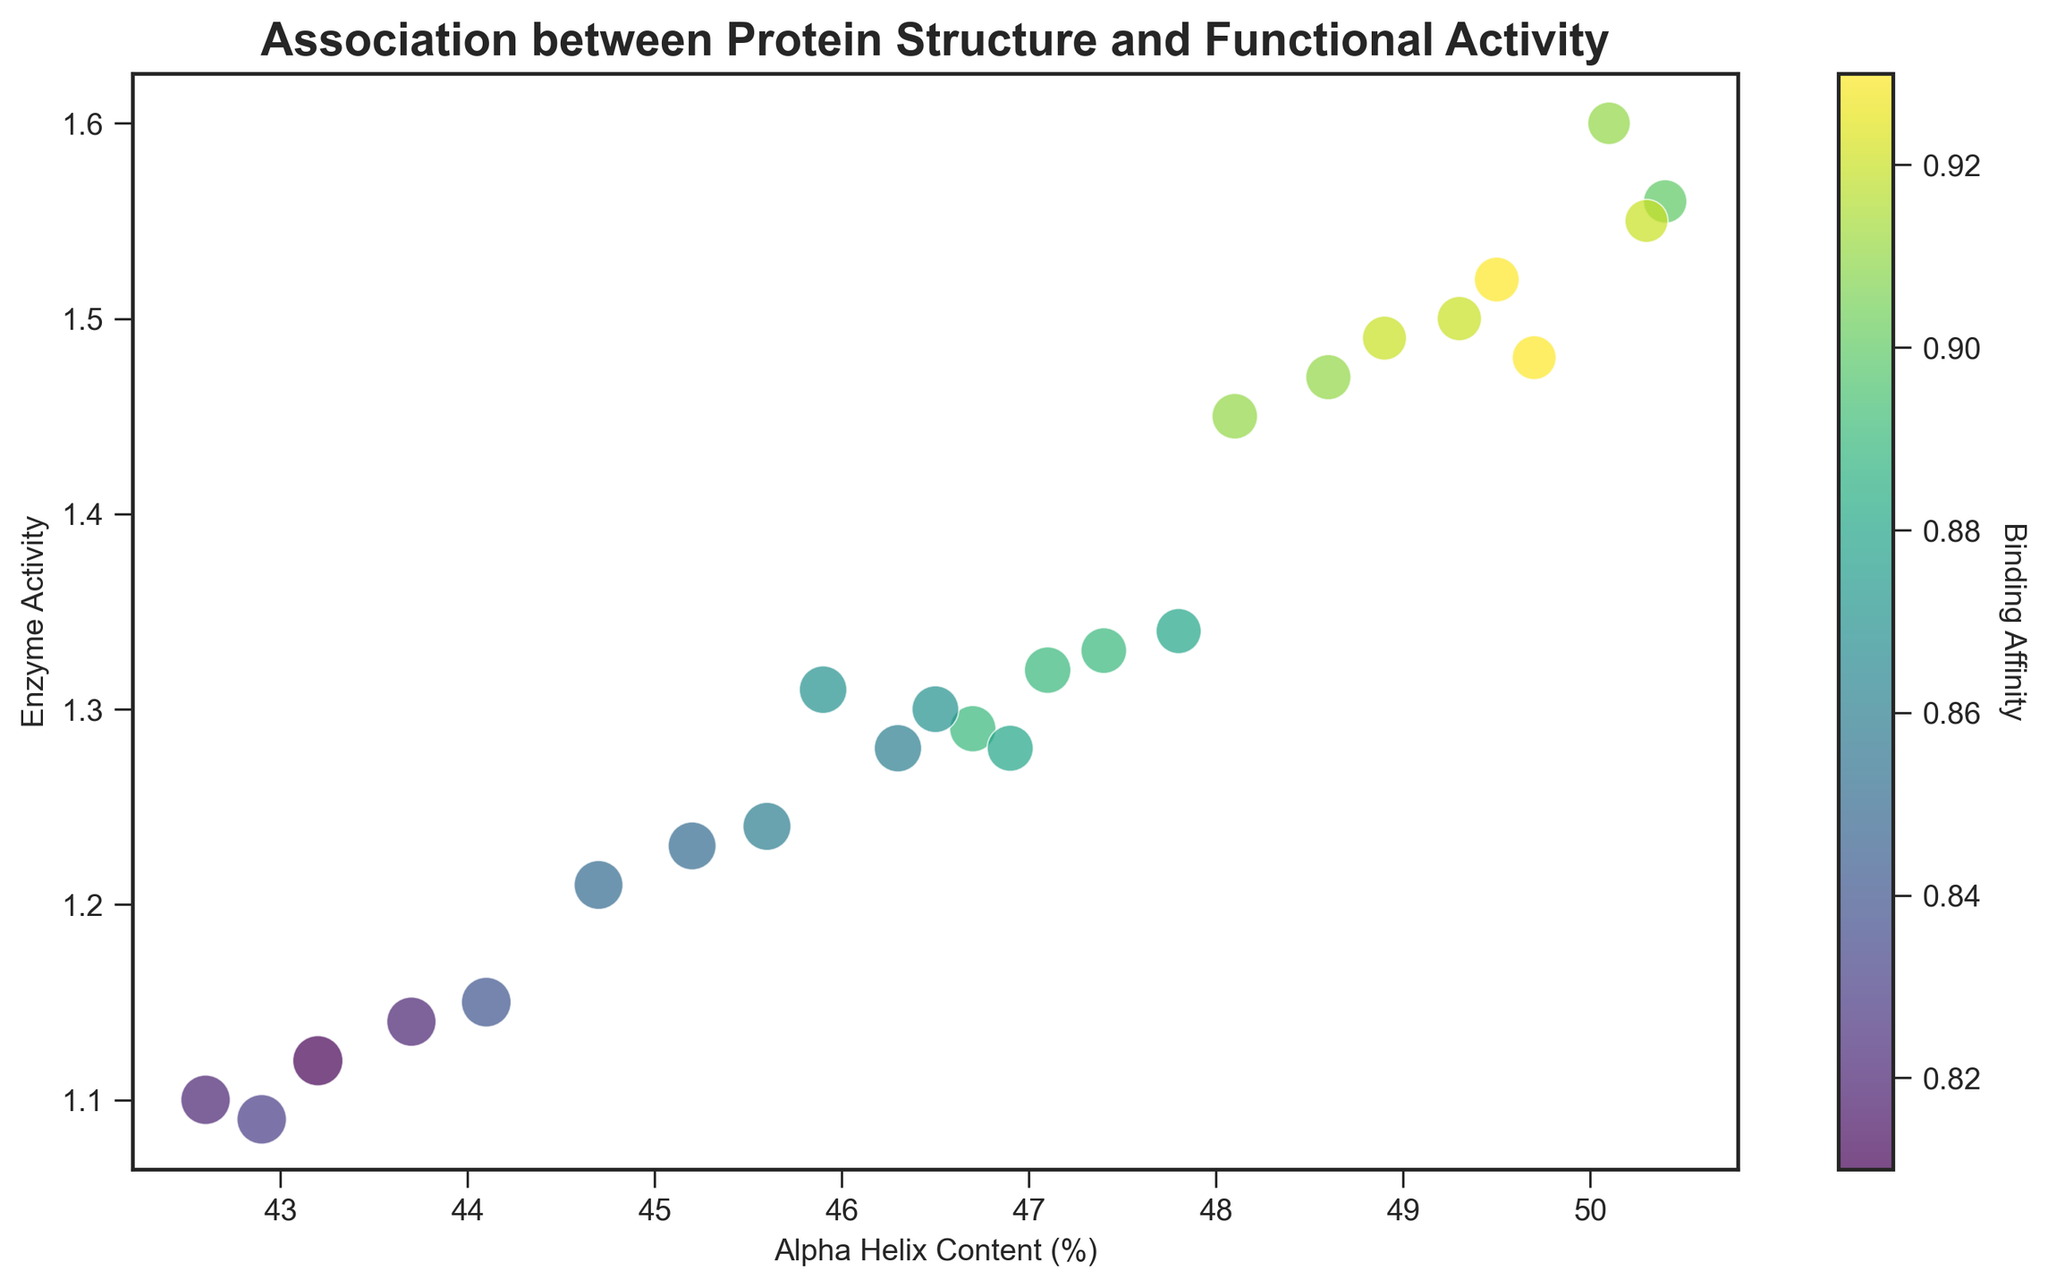What does the size of each point represent in the scatter plot? The size of each point in the scatter plot represents the Beta Sheet Content of the protein, with larger points indicating higher Beta Sheet Content.
Answer: Beta Sheet Content Which protein shows the highest enzyme activity, and what is its alpha helix content? By looking at the scatter plot, the highest enzyme activity is represented by the highest positioned point on the y-axis. The protein with the highest enzyme activity has an activity of 1.60 and an alpha helix content of 50.1%.
Answer: P9, 50.1% How is the Binding Affinity visually represented in the scatter plot? The Binding Affinity is represented by the color intensity of each point. Points with higher Binding Affinities are colored in a more intense color on the viridis scale, which varies from blue to yellow.
Answer: Color intensity What relationship can be observed between Alpha Helix Content and Enzyme Activity for the proteins with the highest Binding Affinity? By observing the points with the highest color intensity (yellow), we can see they generally have high alpha helix content and high enzyme activity, suggesting a positive relationship between these attributes for high Binding Affinity proteins.
Answer: Positive relationship Which protein has the smallest Beta Sheet Content and what is its Binding Affinity? Look for the smallest points in the scatter plot to find the protein with the smallest Beta Sheet Content. The smallest point corresponds to a Beta Sheet Content of 19.8, with a Binding Affinity of 0.91.
Answer: P9, 0.91 Is there any protein with a high Alpha Helix Content but relatively low Enzyme Activity? Identify points on the far right of the x-axis (high alpha helix content) but low on the y-axis (low enzyme activity). Protein P19 has 50.3% alpha helix content but only 1.55 enzyme activity, which is relatively lower compared to other high alpha helix content proteins.
Answer: Yes, P19 Considering the Binding Affinity, which region of the scatter plot tends to have lower values and how is this indicated? Lower Binding Affinity values are indicated by darker blue colors in the scatter plot and are generally found in the lower left region, corresponding to lower alpha helix content and lower enzyme activity.
Answer: Lower left region Comparing P8 and P14, which one has a higher Beta Sheet Content and which has a higher Enzyme Activity? Compare the size and position of the points representing P8 and P14. P8's point is larger (indicating higher Beta Sheet Content of 22.0) and positioned higher on the y-axis (indicating higher Enzyme Activity of 1.52) than P14, which has a Beta Sheet Content of 21.1 and Enzyme Activity of 1.48.
Answer: P8 for both What trend can be observed between the Alpha Helix Content and Binding Affinity? Observe the scatter plot for patterns in color along the x-axis. Generally, as the Alpha Helix Content increases, the color intensity of the points also increases, indicating a positive correlation between Alpha Helix Content and Binding Affinity.
Answer: Positive correlation When you consider both Enzyme Activity and Beta Sheet Content, which protein stands out the most visually and why? Look for the largest and highest point on the plot. Protein P9 stands out the most with the highest enzyme activity of 1.60 and a considerable Beta Sheet Content of 19.8, making it visually distinct with a high position and moderate size.
Answer: P9 